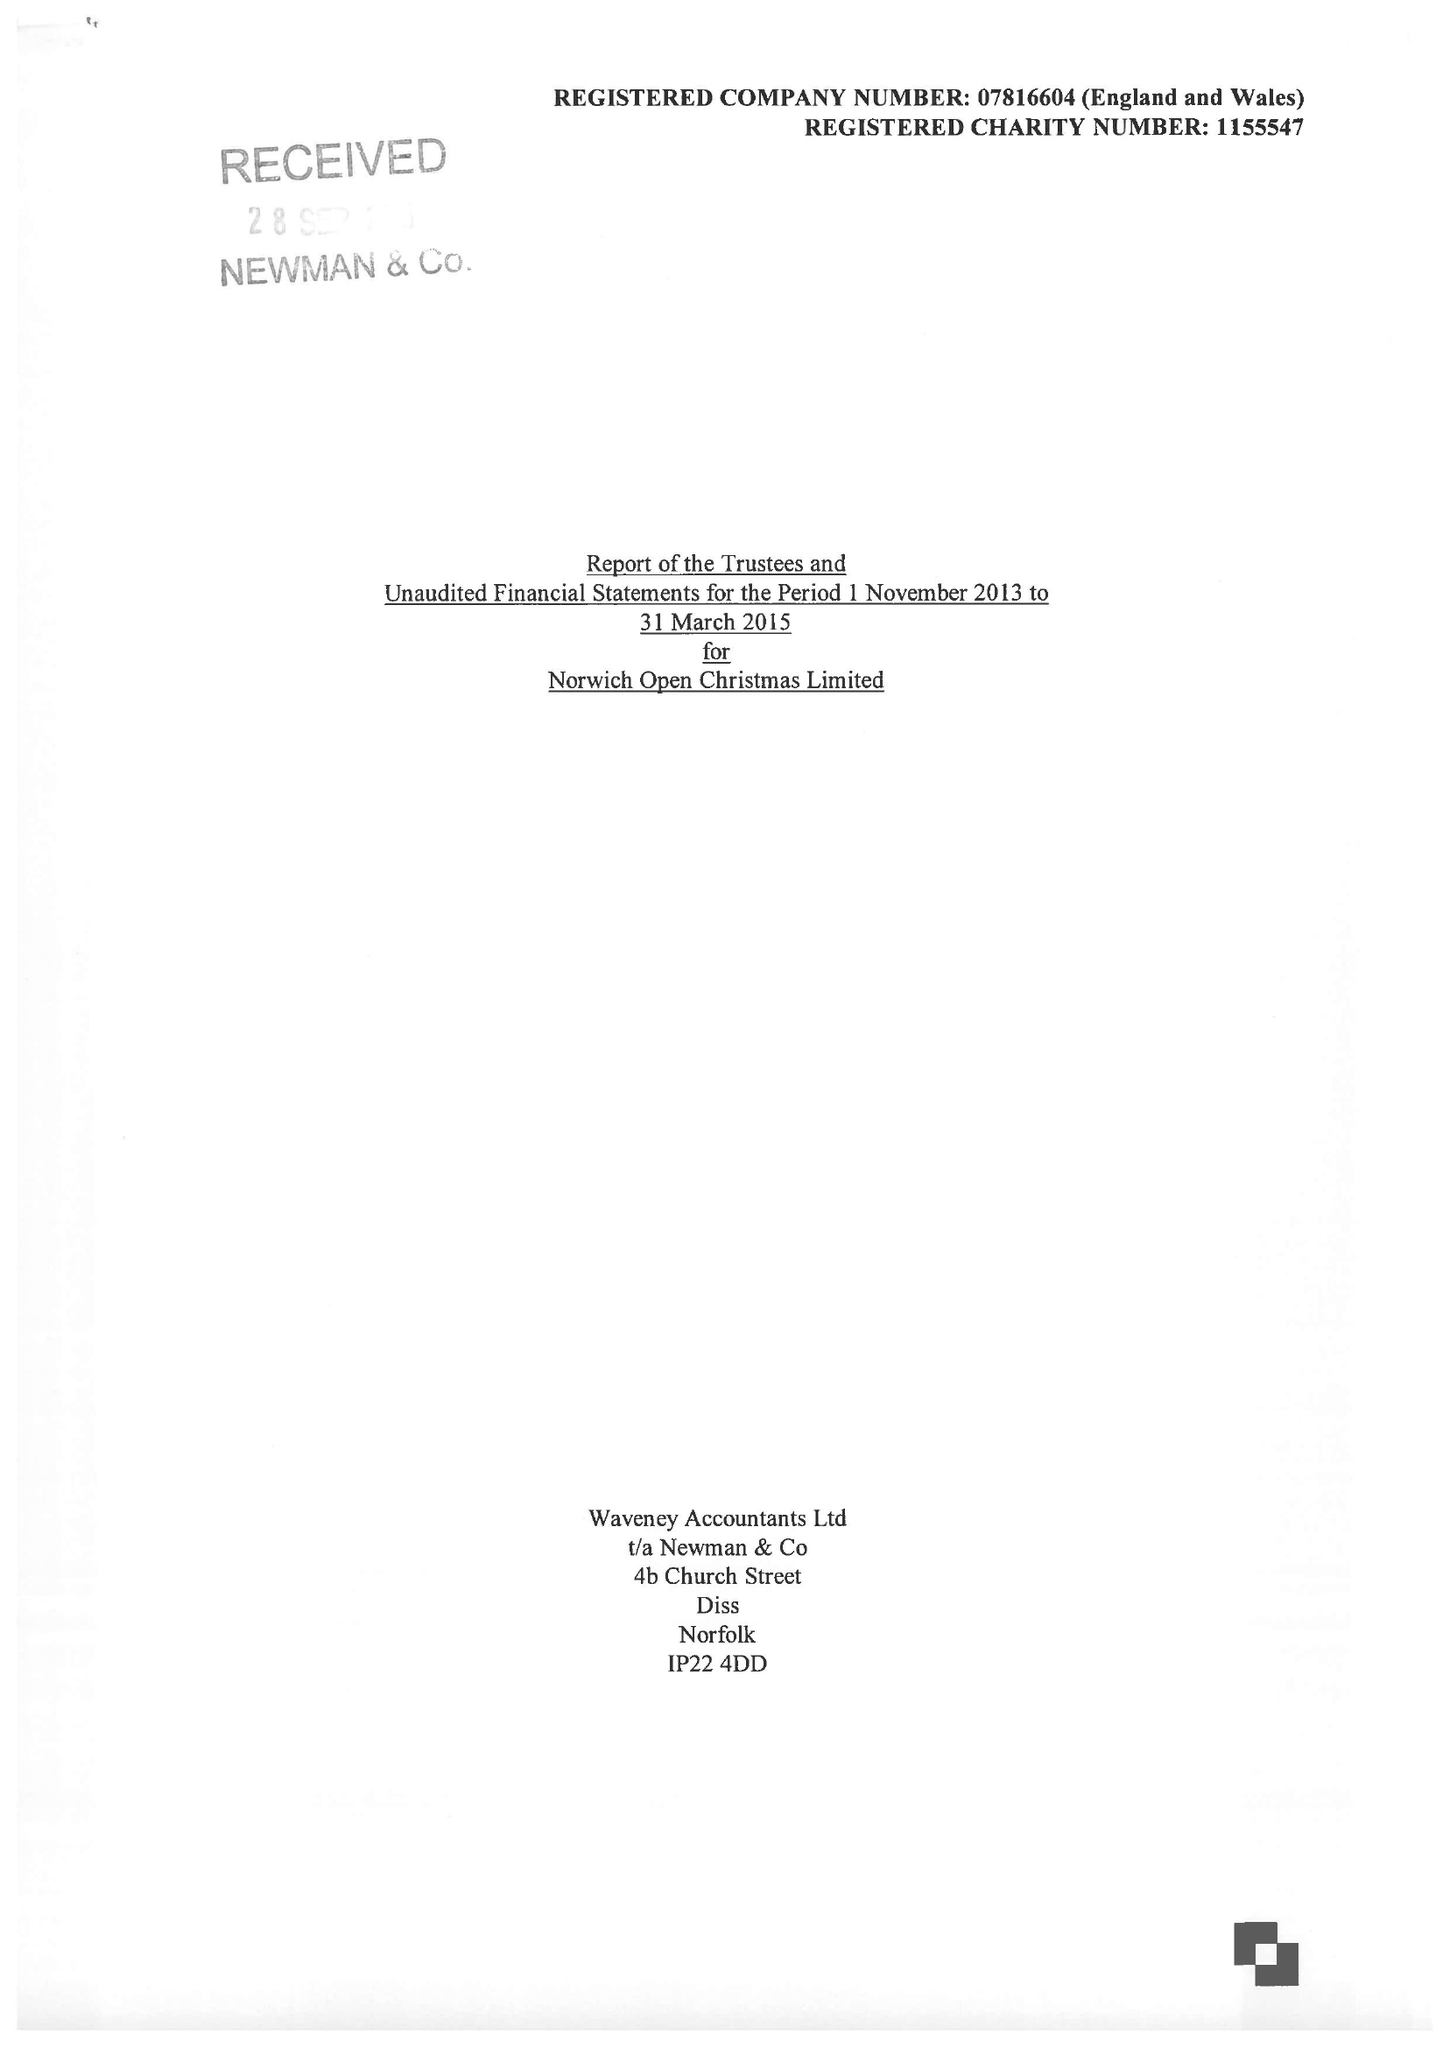What is the value for the spending_annually_in_british_pounds?
Answer the question using a single word or phrase. 5372.00 